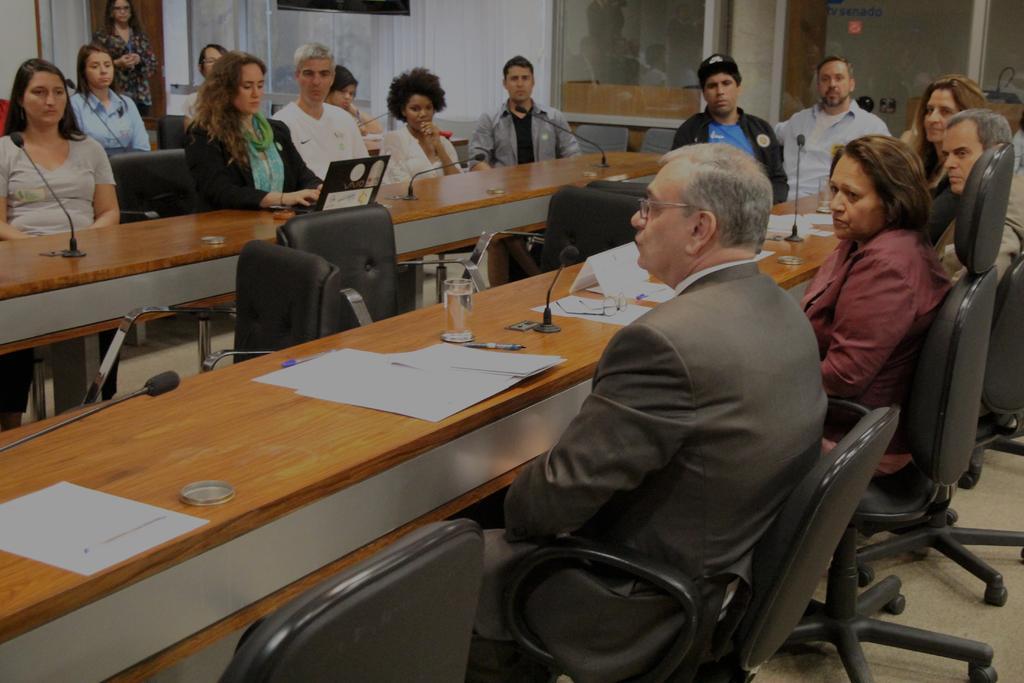In one or two sentences, can you explain what this image depicts? Here we can see a group of persons are sitting on the chair, and in front here is the table and papers glasses and microphone, and some objects on it. 